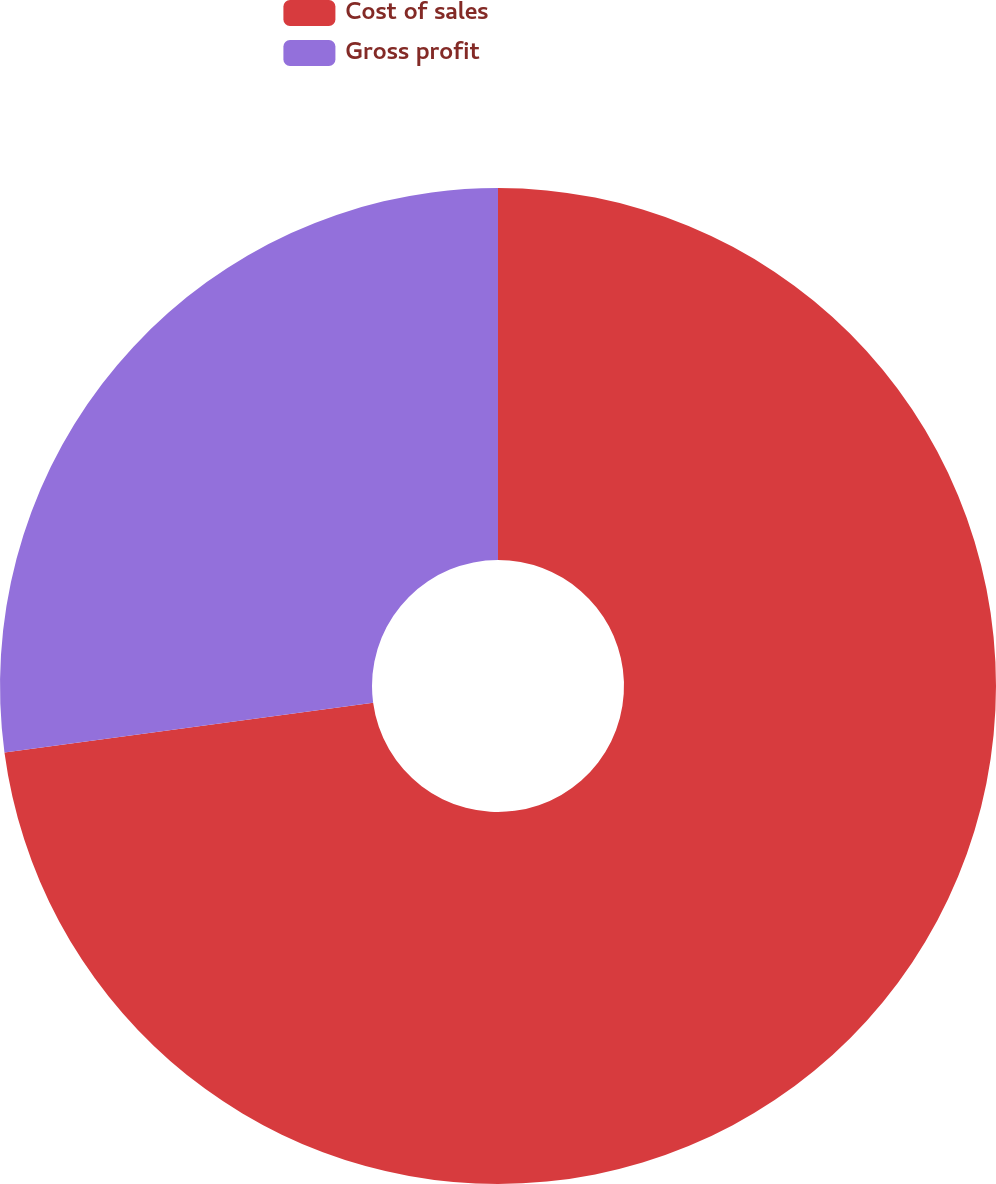Convert chart. <chart><loc_0><loc_0><loc_500><loc_500><pie_chart><fcel>Cost of sales<fcel>Gross profit<nl><fcel>72.87%<fcel>27.13%<nl></chart> 